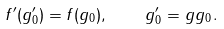Convert formula to latex. <formula><loc_0><loc_0><loc_500><loc_500>f ^ { \prime } ( g _ { 0 } ^ { \prime } ) = f ( g _ { 0 } ) , \quad g _ { 0 } ^ { \prime } = g g _ { 0 } .</formula> 